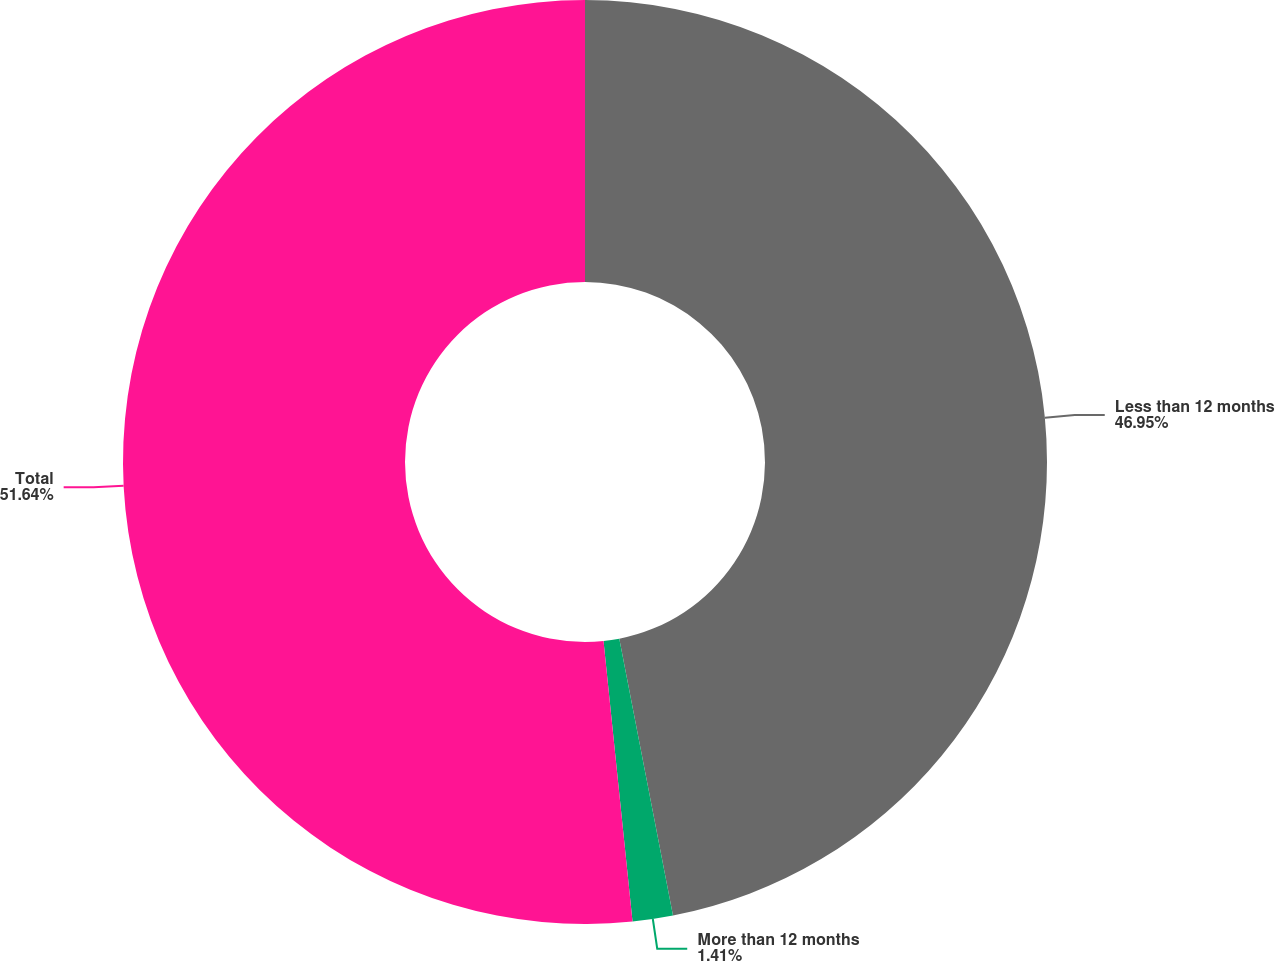Convert chart to OTSL. <chart><loc_0><loc_0><loc_500><loc_500><pie_chart><fcel>Less than 12 months<fcel>More than 12 months<fcel>Total<nl><fcel>46.95%<fcel>1.41%<fcel>51.64%<nl></chart> 